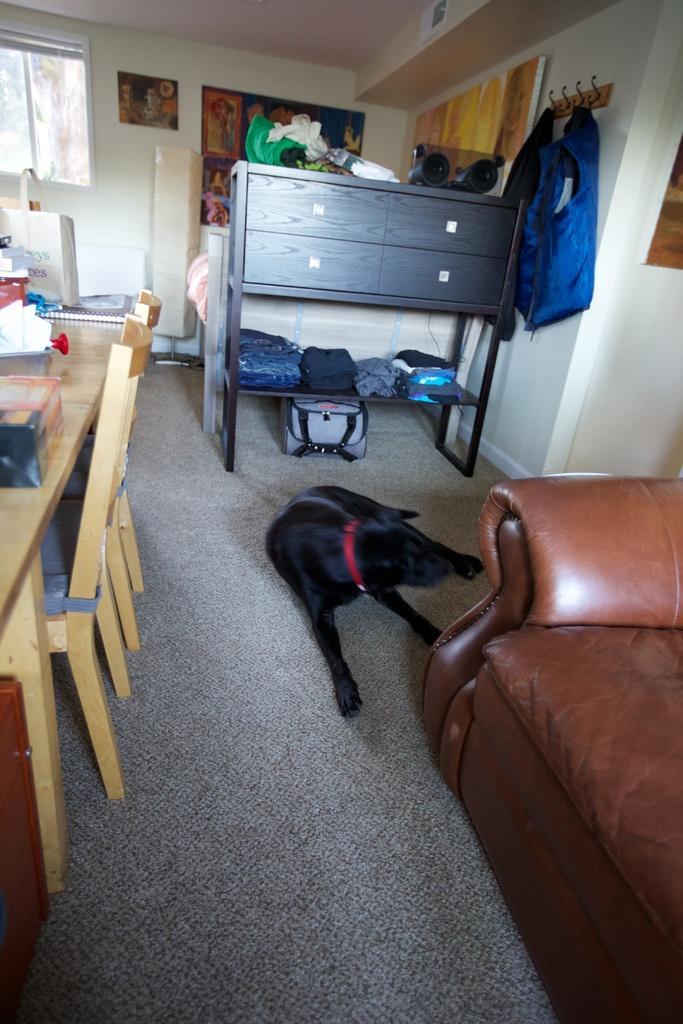In one or two sentences, can you explain what this image depicts? In the center we can see the dog. On the left we can see table and chairs,on table we can see some objects. On the right we can see couch. Coming to background we can see locker table,hanger,cloth,wall,window and frame and few more objects. 